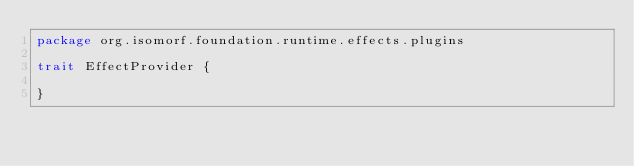Convert code to text. <code><loc_0><loc_0><loc_500><loc_500><_Scala_>package org.isomorf.foundation.runtime.effects.plugins

trait EffectProvider {

}
</code> 